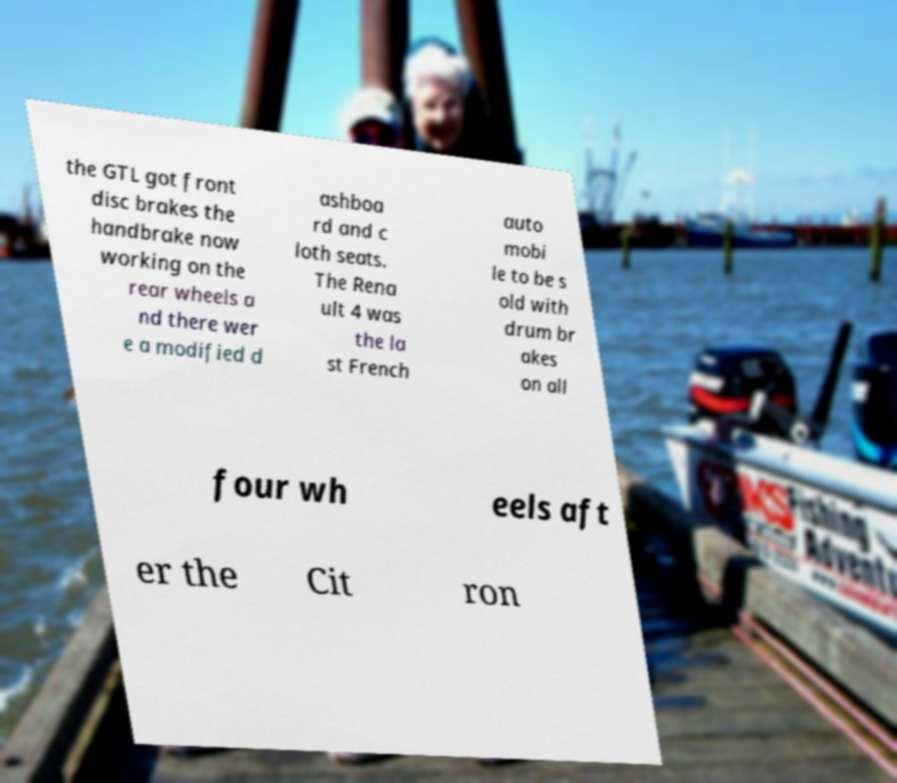Could you extract and type out the text from this image? the GTL got front disc brakes the handbrake now working on the rear wheels a nd there wer e a modified d ashboa rd and c loth seats. The Rena ult 4 was the la st French auto mobi le to be s old with drum br akes on all four wh eels aft er the Cit ron 